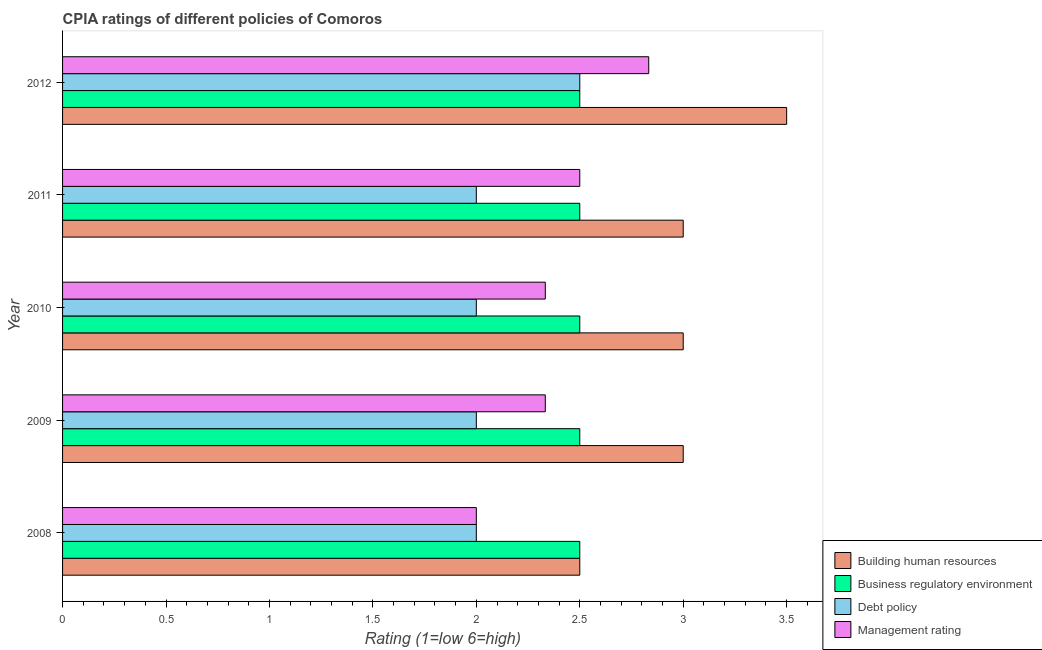Are the number of bars on each tick of the Y-axis equal?
Provide a short and direct response. Yes. How many bars are there on the 2nd tick from the top?
Provide a succinct answer. 4. How many bars are there on the 1st tick from the bottom?
Offer a terse response. 4. What is the label of the 2nd group of bars from the top?
Give a very brief answer. 2011. In how many cases, is the number of bars for a given year not equal to the number of legend labels?
Ensure brevity in your answer.  0. What is the cpia rating of business regulatory environment in 2011?
Provide a succinct answer. 2.5. What is the total cpia rating of business regulatory environment in the graph?
Offer a very short reply. 12.5. What is the difference between the cpia rating of business regulatory environment in 2010 and that in 2012?
Offer a very short reply. 0. What is the difference between the cpia rating of debt policy in 2009 and the cpia rating of building human resources in 2011?
Keep it short and to the point. -1. What is the average cpia rating of business regulatory environment per year?
Offer a very short reply. 2.5. In the year 2012, what is the difference between the cpia rating of business regulatory environment and cpia rating of management?
Ensure brevity in your answer.  -0.33. In how many years, is the cpia rating of debt policy greater than 2.4 ?
Ensure brevity in your answer.  1. What is the ratio of the cpia rating of debt policy in 2010 to that in 2011?
Give a very brief answer. 1. Is the difference between the cpia rating of business regulatory environment in 2009 and 2012 greater than the difference between the cpia rating of management in 2009 and 2012?
Your answer should be compact. Yes. What is the difference between the highest and the lowest cpia rating of management?
Your answer should be very brief. 0.83. Is it the case that in every year, the sum of the cpia rating of building human resources and cpia rating of management is greater than the sum of cpia rating of business regulatory environment and cpia rating of debt policy?
Provide a succinct answer. No. What does the 4th bar from the top in 2008 represents?
Provide a short and direct response. Building human resources. What does the 1st bar from the bottom in 2008 represents?
Offer a terse response. Building human resources. Are all the bars in the graph horizontal?
Offer a terse response. Yes. How many years are there in the graph?
Your response must be concise. 5. What is the difference between two consecutive major ticks on the X-axis?
Offer a terse response. 0.5. Does the graph contain any zero values?
Keep it short and to the point. No. Does the graph contain grids?
Give a very brief answer. No. What is the title of the graph?
Your response must be concise. CPIA ratings of different policies of Comoros. What is the label or title of the X-axis?
Give a very brief answer. Rating (1=low 6=high). What is the label or title of the Y-axis?
Your answer should be very brief. Year. What is the Rating (1=low 6=high) of Management rating in 2008?
Keep it short and to the point. 2. What is the Rating (1=low 6=high) of Building human resources in 2009?
Offer a very short reply. 3. What is the Rating (1=low 6=high) in Business regulatory environment in 2009?
Your answer should be very brief. 2.5. What is the Rating (1=low 6=high) in Management rating in 2009?
Make the answer very short. 2.33. What is the Rating (1=low 6=high) of Building human resources in 2010?
Your answer should be compact. 3. What is the Rating (1=low 6=high) of Debt policy in 2010?
Offer a terse response. 2. What is the Rating (1=low 6=high) of Management rating in 2010?
Make the answer very short. 2.33. What is the Rating (1=low 6=high) in Building human resources in 2011?
Provide a succinct answer. 3. What is the Rating (1=low 6=high) in Business regulatory environment in 2011?
Keep it short and to the point. 2.5. What is the Rating (1=low 6=high) of Debt policy in 2011?
Make the answer very short. 2. What is the Rating (1=low 6=high) in Business regulatory environment in 2012?
Your answer should be compact. 2.5. What is the Rating (1=low 6=high) in Debt policy in 2012?
Ensure brevity in your answer.  2.5. What is the Rating (1=low 6=high) of Management rating in 2012?
Provide a succinct answer. 2.83. Across all years, what is the maximum Rating (1=low 6=high) of Debt policy?
Keep it short and to the point. 2.5. Across all years, what is the maximum Rating (1=low 6=high) of Management rating?
Your response must be concise. 2.83. Across all years, what is the minimum Rating (1=low 6=high) in Building human resources?
Offer a terse response. 2.5. Across all years, what is the minimum Rating (1=low 6=high) in Management rating?
Your answer should be compact. 2. What is the total Rating (1=low 6=high) of Debt policy in the graph?
Ensure brevity in your answer.  10.5. What is the difference between the Rating (1=low 6=high) of Business regulatory environment in 2008 and that in 2009?
Make the answer very short. 0. What is the difference between the Rating (1=low 6=high) in Management rating in 2008 and that in 2009?
Offer a terse response. -0.33. What is the difference between the Rating (1=low 6=high) of Building human resources in 2008 and that in 2010?
Provide a short and direct response. -0.5. What is the difference between the Rating (1=low 6=high) in Business regulatory environment in 2008 and that in 2010?
Your answer should be compact. 0. What is the difference between the Rating (1=low 6=high) in Debt policy in 2008 and that in 2010?
Give a very brief answer. 0. What is the difference between the Rating (1=low 6=high) of Management rating in 2008 and that in 2010?
Your answer should be compact. -0.33. What is the difference between the Rating (1=low 6=high) in Building human resources in 2008 and that in 2011?
Give a very brief answer. -0.5. What is the difference between the Rating (1=low 6=high) of Business regulatory environment in 2008 and that in 2011?
Provide a succinct answer. 0. What is the difference between the Rating (1=low 6=high) of Management rating in 2008 and that in 2011?
Your answer should be compact. -0.5. What is the difference between the Rating (1=low 6=high) in Building human resources in 2008 and that in 2012?
Your answer should be very brief. -1. What is the difference between the Rating (1=low 6=high) of Business regulatory environment in 2008 and that in 2012?
Keep it short and to the point. 0. What is the difference between the Rating (1=low 6=high) of Management rating in 2008 and that in 2012?
Your response must be concise. -0.83. What is the difference between the Rating (1=low 6=high) in Building human resources in 2009 and that in 2010?
Ensure brevity in your answer.  0. What is the difference between the Rating (1=low 6=high) in Debt policy in 2009 and that in 2010?
Give a very brief answer. 0. What is the difference between the Rating (1=low 6=high) in Management rating in 2009 and that in 2010?
Offer a terse response. 0. What is the difference between the Rating (1=low 6=high) of Building human resources in 2009 and that in 2011?
Ensure brevity in your answer.  0. What is the difference between the Rating (1=low 6=high) in Business regulatory environment in 2009 and that in 2011?
Make the answer very short. 0. What is the difference between the Rating (1=low 6=high) of Management rating in 2009 and that in 2012?
Make the answer very short. -0.5. What is the difference between the Rating (1=low 6=high) in Building human resources in 2010 and that in 2011?
Offer a very short reply. 0. What is the difference between the Rating (1=low 6=high) in Debt policy in 2010 and that in 2011?
Keep it short and to the point. 0. What is the difference between the Rating (1=low 6=high) in Building human resources in 2010 and that in 2012?
Give a very brief answer. -0.5. What is the difference between the Rating (1=low 6=high) of Business regulatory environment in 2010 and that in 2012?
Provide a short and direct response. 0. What is the difference between the Rating (1=low 6=high) in Debt policy in 2010 and that in 2012?
Your answer should be compact. -0.5. What is the difference between the Rating (1=low 6=high) in Management rating in 2010 and that in 2012?
Offer a very short reply. -0.5. What is the difference between the Rating (1=low 6=high) in Business regulatory environment in 2011 and that in 2012?
Your answer should be compact. 0. What is the difference between the Rating (1=low 6=high) in Management rating in 2011 and that in 2012?
Offer a very short reply. -0.33. What is the difference between the Rating (1=low 6=high) in Debt policy in 2008 and the Rating (1=low 6=high) in Management rating in 2009?
Your answer should be very brief. -0.33. What is the difference between the Rating (1=low 6=high) in Building human resources in 2008 and the Rating (1=low 6=high) in Business regulatory environment in 2010?
Ensure brevity in your answer.  0. What is the difference between the Rating (1=low 6=high) in Building human resources in 2008 and the Rating (1=low 6=high) in Management rating in 2010?
Your answer should be compact. 0.17. What is the difference between the Rating (1=low 6=high) of Business regulatory environment in 2008 and the Rating (1=low 6=high) of Debt policy in 2010?
Ensure brevity in your answer.  0.5. What is the difference between the Rating (1=low 6=high) in Business regulatory environment in 2008 and the Rating (1=low 6=high) in Management rating in 2010?
Your answer should be compact. 0.17. What is the difference between the Rating (1=low 6=high) of Debt policy in 2008 and the Rating (1=low 6=high) of Management rating in 2010?
Offer a terse response. -0.33. What is the difference between the Rating (1=low 6=high) in Building human resources in 2008 and the Rating (1=low 6=high) in Debt policy in 2011?
Provide a succinct answer. 0.5. What is the difference between the Rating (1=low 6=high) in Business regulatory environment in 2008 and the Rating (1=low 6=high) in Management rating in 2011?
Offer a very short reply. 0. What is the difference between the Rating (1=low 6=high) in Building human resources in 2008 and the Rating (1=low 6=high) in Debt policy in 2012?
Offer a very short reply. 0. What is the difference between the Rating (1=low 6=high) in Debt policy in 2008 and the Rating (1=low 6=high) in Management rating in 2012?
Provide a short and direct response. -0.83. What is the difference between the Rating (1=low 6=high) in Building human resources in 2009 and the Rating (1=low 6=high) in Business regulatory environment in 2010?
Offer a terse response. 0.5. What is the difference between the Rating (1=low 6=high) in Business regulatory environment in 2009 and the Rating (1=low 6=high) in Debt policy in 2010?
Your answer should be very brief. 0.5. What is the difference between the Rating (1=low 6=high) of Business regulatory environment in 2009 and the Rating (1=low 6=high) of Management rating in 2010?
Make the answer very short. 0.17. What is the difference between the Rating (1=low 6=high) of Building human resources in 2009 and the Rating (1=low 6=high) of Debt policy in 2011?
Provide a succinct answer. 1. What is the difference between the Rating (1=low 6=high) of Building human resources in 2009 and the Rating (1=low 6=high) of Management rating in 2011?
Make the answer very short. 0.5. What is the difference between the Rating (1=low 6=high) in Business regulatory environment in 2009 and the Rating (1=low 6=high) in Management rating in 2011?
Make the answer very short. 0. What is the difference between the Rating (1=low 6=high) in Business regulatory environment in 2009 and the Rating (1=low 6=high) in Management rating in 2012?
Keep it short and to the point. -0.33. What is the difference between the Rating (1=low 6=high) in Debt policy in 2009 and the Rating (1=low 6=high) in Management rating in 2012?
Provide a succinct answer. -0.83. What is the difference between the Rating (1=low 6=high) of Business regulatory environment in 2010 and the Rating (1=low 6=high) of Management rating in 2011?
Make the answer very short. 0. What is the difference between the Rating (1=low 6=high) of Building human resources in 2010 and the Rating (1=low 6=high) of Debt policy in 2012?
Give a very brief answer. 0.5. What is the difference between the Rating (1=low 6=high) of Building human resources in 2010 and the Rating (1=low 6=high) of Management rating in 2012?
Provide a short and direct response. 0.17. What is the difference between the Rating (1=low 6=high) in Debt policy in 2010 and the Rating (1=low 6=high) in Management rating in 2012?
Keep it short and to the point. -0.83. What is the difference between the Rating (1=low 6=high) in Building human resources in 2011 and the Rating (1=low 6=high) in Business regulatory environment in 2012?
Give a very brief answer. 0.5. What is the difference between the Rating (1=low 6=high) in Building human resources in 2011 and the Rating (1=low 6=high) in Debt policy in 2012?
Provide a short and direct response. 0.5. What is the difference between the Rating (1=low 6=high) of Building human resources in 2011 and the Rating (1=low 6=high) of Management rating in 2012?
Offer a terse response. 0.17. What is the difference between the Rating (1=low 6=high) of Business regulatory environment in 2011 and the Rating (1=low 6=high) of Debt policy in 2012?
Your answer should be compact. 0. What is the average Rating (1=low 6=high) in Business regulatory environment per year?
Provide a short and direct response. 2.5. What is the average Rating (1=low 6=high) in Debt policy per year?
Your answer should be very brief. 2.1. In the year 2008, what is the difference between the Rating (1=low 6=high) in Building human resources and Rating (1=low 6=high) in Business regulatory environment?
Your answer should be very brief. 0. In the year 2008, what is the difference between the Rating (1=low 6=high) of Building human resources and Rating (1=low 6=high) of Debt policy?
Your answer should be compact. 0.5. In the year 2008, what is the difference between the Rating (1=low 6=high) of Building human resources and Rating (1=low 6=high) of Management rating?
Provide a short and direct response. 0.5. In the year 2009, what is the difference between the Rating (1=low 6=high) of Building human resources and Rating (1=low 6=high) of Management rating?
Keep it short and to the point. 0.67. In the year 2009, what is the difference between the Rating (1=low 6=high) in Debt policy and Rating (1=low 6=high) in Management rating?
Give a very brief answer. -0.33. In the year 2010, what is the difference between the Rating (1=low 6=high) in Building human resources and Rating (1=low 6=high) in Business regulatory environment?
Your answer should be compact. 0.5. In the year 2010, what is the difference between the Rating (1=low 6=high) of Building human resources and Rating (1=low 6=high) of Debt policy?
Your answer should be very brief. 1. In the year 2010, what is the difference between the Rating (1=low 6=high) of Business regulatory environment and Rating (1=low 6=high) of Management rating?
Ensure brevity in your answer.  0.17. In the year 2011, what is the difference between the Rating (1=low 6=high) in Business regulatory environment and Rating (1=low 6=high) in Debt policy?
Offer a very short reply. 0.5. In the year 2011, what is the difference between the Rating (1=low 6=high) in Business regulatory environment and Rating (1=low 6=high) in Management rating?
Give a very brief answer. 0. In the year 2012, what is the difference between the Rating (1=low 6=high) of Building human resources and Rating (1=low 6=high) of Business regulatory environment?
Your response must be concise. 1. In the year 2012, what is the difference between the Rating (1=low 6=high) of Building human resources and Rating (1=low 6=high) of Debt policy?
Provide a short and direct response. 1. In the year 2012, what is the difference between the Rating (1=low 6=high) of Debt policy and Rating (1=low 6=high) of Management rating?
Your response must be concise. -0.33. What is the ratio of the Rating (1=low 6=high) in Business regulatory environment in 2008 to that in 2010?
Provide a succinct answer. 1. What is the ratio of the Rating (1=low 6=high) of Debt policy in 2008 to that in 2010?
Your answer should be very brief. 1. What is the ratio of the Rating (1=low 6=high) in Management rating in 2008 to that in 2010?
Provide a succinct answer. 0.86. What is the ratio of the Rating (1=low 6=high) of Debt policy in 2008 to that in 2011?
Offer a terse response. 1. What is the ratio of the Rating (1=low 6=high) in Debt policy in 2008 to that in 2012?
Your answer should be compact. 0.8. What is the ratio of the Rating (1=low 6=high) in Management rating in 2008 to that in 2012?
Make the answer very short. 0.71. What is the ratio of the Rating (1=low 6=high) in Building human resources in 2009 to that in 2010?
Offer a terse response. 1. What is the ratio of the Rating (1=low 6=high) of Building human resources in 2009 to that in 2011?
Your response must be concise. 1. What is the ratio of the Rating (1=low 6=high) in Business regulatory environment in 2009 to that in 2011?
Offer a very short reply. 1. What is the ratio of the Rating (1=low 6=high) of Debt policy in 2009 to that in 2011?
Your response must be concise. 1. What is the ratio of the Rating (1=low 6=high) in Management rating in 2009 to that in 2011?
Provide a short and direct response. 0.93. What is the ratio of the Rating (1=low 6=high) in Building human resources in 2009 to that in 2012?
Keep it short and to the point. 0.86. What is the ratio of the Rating (1=low 6=high) in Debt policy in 2009 to that in 2012?
Provide a succinct answer. 0.8. What is the ratio of the Rating (1=low 6=high) in Management rating in 2009 to that in 2012?
Your response must be concise. 0.82. What is the ratio of the Rating (1=low 6=high) of Building human resources in 2010 to that in 2011?
Your answer should be very brief. 1. What is the ratio of the Rating (1=low 6=high) of Business regulatory environment in 2010 to that in 2011?
Your answer should be very brief. 1. What is the ratio of the Rating (1=low 6=high) in Management rating in 2010 to that in 2011?
Your answer should be compact. 0.93. What is the ratio of the Rating (1=low 6=high) of Management rating in 2010 to that in 2012?
Your answer should be compact. 0.82. What is the ratio of the Rating (1=low 6=high) in Management rating in 2011 to that in 2012?
Your response must be concise. 0.88. What is the difference between the highest and the second highest Rating (1=low 6=high) of Management rating?
Your response must be concise. 0.33. What is the difference between the highest and the lowest Rating (1=low 6=high) of Management rating?
Provide a short and direct response. 0.83. 